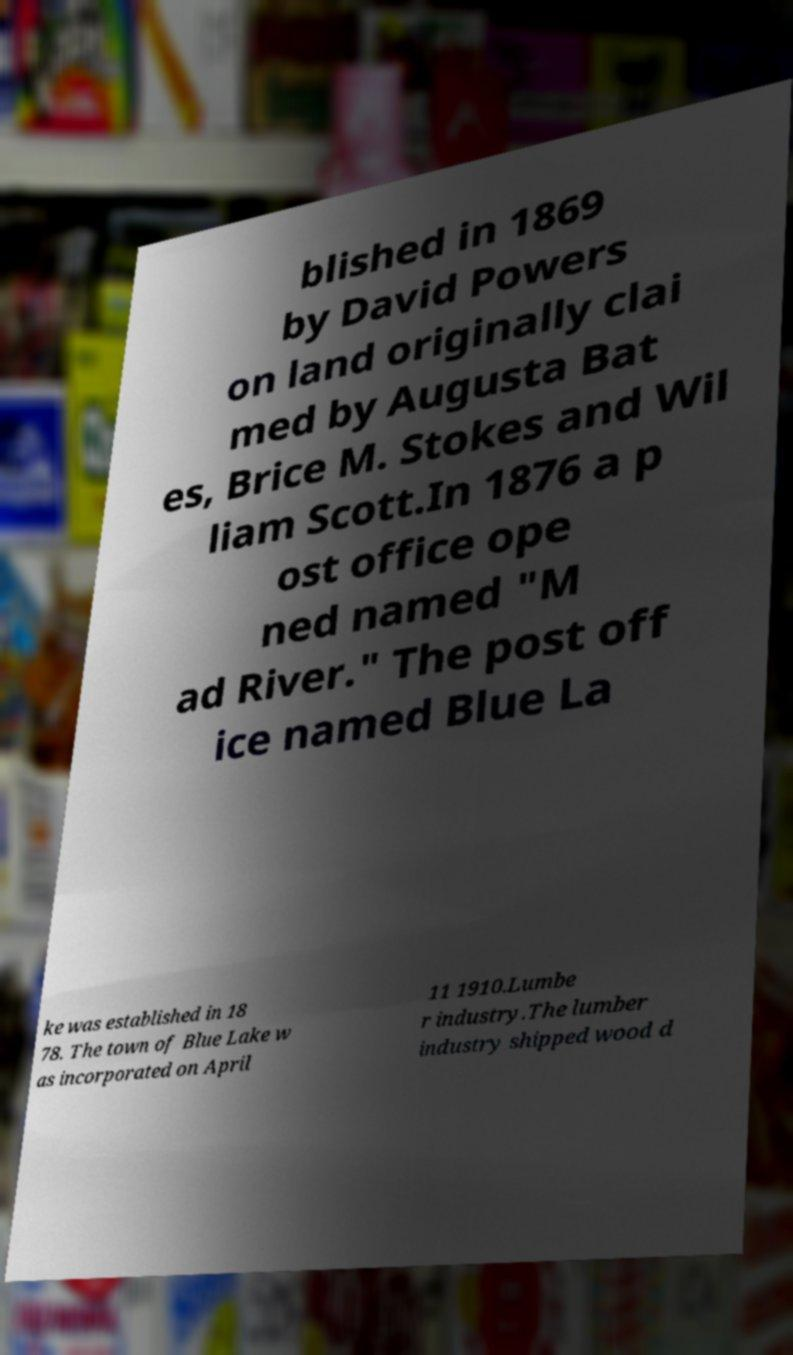Can you accurately transcribe the text from the provided image for me? blished in 1869 by David Powers on land originally clai med by Augusta Bat es, Brice M. Stokes and Wil liam Scott.In 1876 a p ost office ope ned named "M ad River." The post off ice named Blue La ke was established in 18 78. The town of Blue Lake w as incorporated on April 11 1910.Lumbe r industry.The lumber industry shipped wood d 